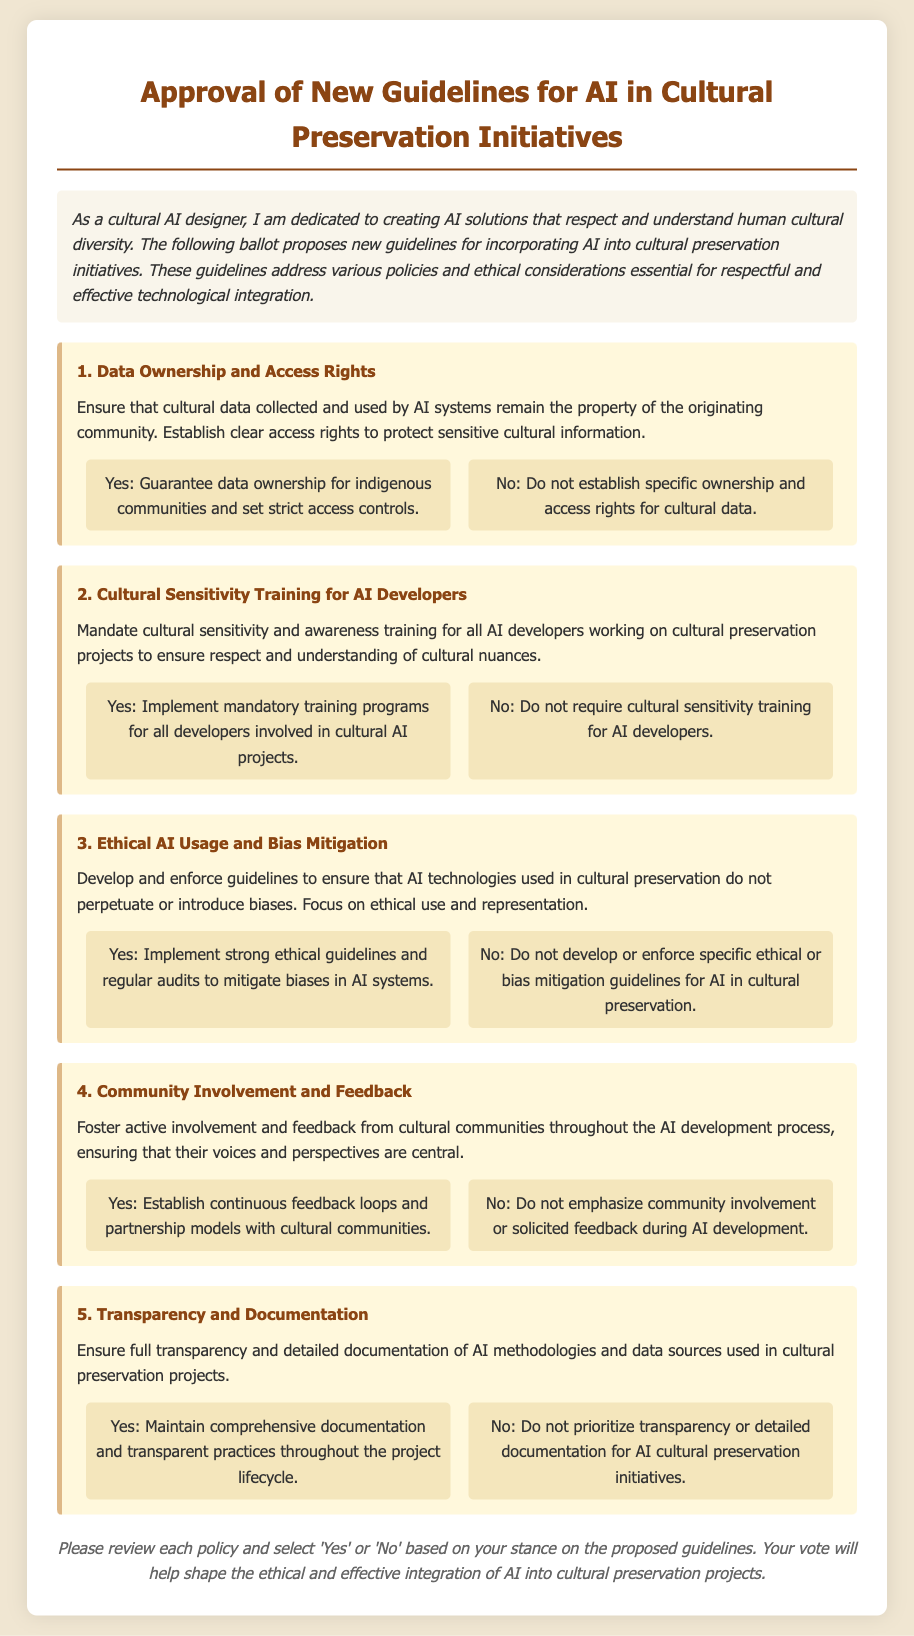What is the title of the ballot? The title of the ballot is located at the top of the document and indicates the primary subject matter.
Answer: Approval of New Guidelines for AI in Cultural Preservation Initiatives How many policies are proposed in the ballot? The number of policies is found by counting each distinct policy section presented in the document.
Answer: Five What is the first proposed policy? The first proposed policy is listed at the beginning of the policy section in the document.
Answer: Data Ownership and Access Rights What does the second policy require for AI developers? The requirements for AI developers can be found in the description of the second policy section.
Answer: Cultural sensitivity and awareness training Which policy emphasizes community involvement? The policy that highlights community involvement is identified in its title.
Answer: Community Involvement and Feedback What is required for ethical AI usage according to the third policy? The requirements for ethical AI usage is detailed in the description of the third policy section.
Answer: Guidelines to ensure that AI technologies do not perpetuate biases How should transparency be maintained in cultural preservation initiatives? The expectations for transparency are outlined in the fifth policy description.
Answer: Full transparency and detailed documentation What are voters asked to select for each policy? The action that voters need to take for each policy option is specified at the end of the document.
Answer: Yes or No 